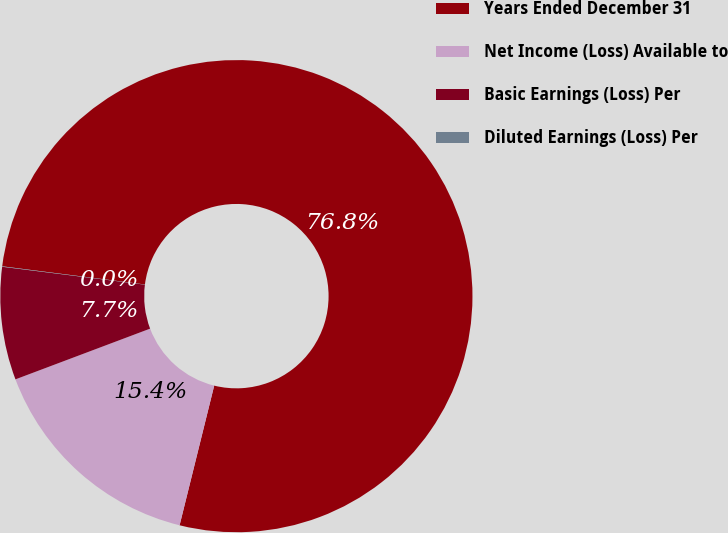<chart> <loc_0><loc_0><loc_500><loc_500><pie_chart><fcel>Years Ended December 31<fcel>Net Income (Loss) Available to<fcel>Basic Earnings (Loss) Per<fcel>Diluted Earnings (Loss) Per<nl><fcel>76.85%<fcel>15.4%<fcel>7.72%<fcel>0.03%<nl></chart> 